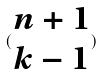Convert formula to latex. <formula><loc_0><loc_0><loc_500><loc_500>( \begin{matrix} n + 1 \\ k - 1 \end{matrix} )</formula> 